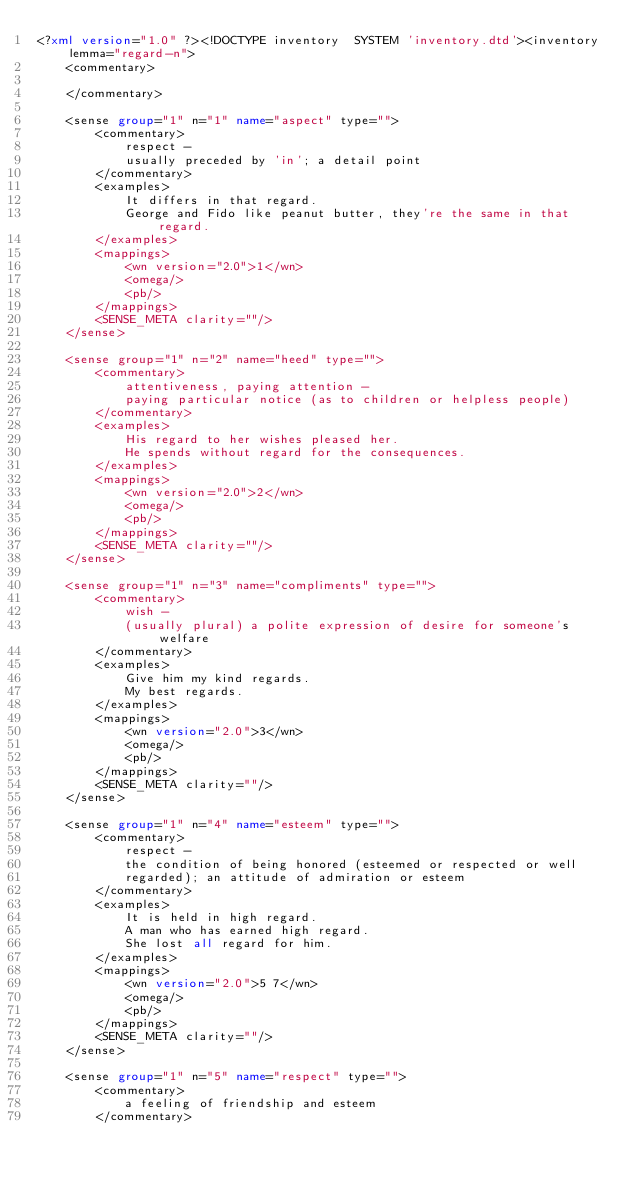<code> <loc_0><loc_0><loc_500><loc_500><_XML_><?xml version="1.0" ?><!DOCTYPE inventory  SYSTEM 'inventory.dtd'><inventory lemma="regard-n">
    <commentary>
        
    </commentary>
    
    <sense group="1" n="1" name="aspect" type="">
        <commentary>
            respect - 
            usually preceded by 'in'; a detail point
        </commentary>
        <examples>
            It differs in that regard.
            George and Fido like peanut butter, they're the same in that regard.
        </examples>
        <mappings>
            <wn version="2.0">1</wn>
            <omega/>
            <pb/>
        </mappings>
        <SENSE_META clarity=""/>
    </sense>
    
    <sense group="1" n="2" name="heed" type="">
        <commentary>
            attentiveness, paying attention - 
            paying particular notice (as to children or helpless people)
        </commentary>
        <examples>
            His regard to her wishes pleased her.
            He spends without regard for the consequences.
        </examples>
        <mappings>
            <wn version="2.0">2</wn>
            <omega/>
            <pb/>
        </mappings>
        <SENSE_META clarity=""/>
    </sense>
    
    <sense group="1" n="3" name="compliments" type="">
        <commentary>
            wish - 
            (usually plural) a polite expression of desire for someone's welfare
        </commentary>
        <examples>
            Give him my kind regards.
            My best regards.
        </examples>
        <mappings>
            <wn version="2.0">3</wn>
            <omega/>
            <pb/>
        </mappings>
        <SENSE_META clarity=""/>
    </sense>
    
    <sense group="1" n="4" name="esteem" type="">
        <commentary>
            respect - 
            the condition of being honored (esteemed or respected or well
            regarded); an attitude of admiration or esteem
        </commentary>
        <examples>
            It is held in high regard.
            A man who has earned high regard.
            She lost all regard for him.
        </examples>
        <mappings>
            <wn version="2.0">5 7</wn>
            <omega/>
            <pb/>
        </mappings>
        <SENSE_META clarity=""/>
    </sense>
    
    <sense group="1" n="5" name="respect" type="">
        <commentary>
            a feeling of friendship and esteem
        </commentary></code> 